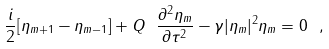<formula> <loc_0><loc_0><loc_500><loc_500>\frac { i } { 2 } [ \eta _ { m + 1 } - \eta _ { m - 1 } ] + Q \ \frac { \partial ^ { 2 } \eta _ { m } } { \partial \tau ^ { 2 } } - \gamma | \eta _ { m } | ^ { 2 } \eta _ { m } = 0 \ ,</formula> 